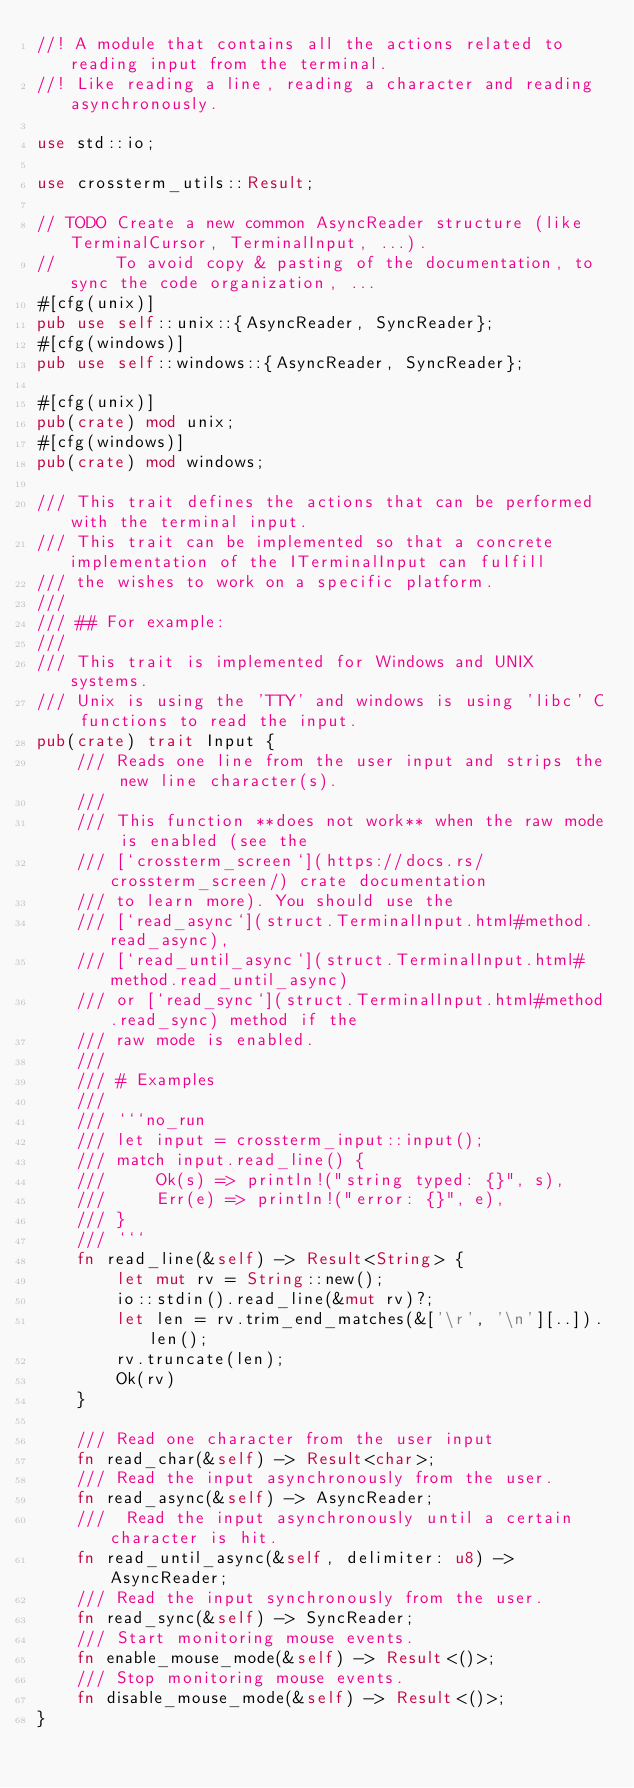Convert code to text. <code><loc_0><loc_0><loc_500><loc_500><_Rust_>//! A module that contains all the actions related to reading input from the terminal.
//! Like reading a line, reading a character and reading asynchronously.

use std::io;

use crossterm_utils::Result;

// TODO Create a new common AsyncReader structure (like TerminalCursor, TerminalInput, ...).
//      To avoid copy & pasting of the documentation, to sync the code organization, ...
#[cfg(unix)]
pub use self::unix::{AsyncReader, SyncReader};
#[cfg(windows)]
pub use self::windows::{AsyncReader, SyncReader};

#[cfg(unix)]
pub(crate) mod unix;
#[cfg(windows)]
pub(crate) mod windows;

/// This trait defines the actions that can be performed with the terminal input.
/// This trait can be implemented so that a concrete implementation of the ITerminalInput can fulfill
/// the wishes to work on a specific platform.
///
/// ## For example:
///
/// This trait is implemented for Windows and UNIX systems.
/// Unix is using the 'TTY' and windows is using 'libc' C functions to read the input.
pub(crate) trait Input {
    /// Reads one line from the user input and strips the new line character(s).
    ///
    /// This function **does not work** when the raw mode is enabled (see the
    /// [`crossterm_screen`](https://docs.rs/crossterm_screen/) crate documentation
    /// to learn more). You should use the
    /// [`read_async`](struct.TerminalInput.html#method.read_async),
    /// [`read_until_async`](struct.TerminalInput.html#method.read_until_async)
    /// or [`read_sync`](struct.TerminalInput.html#method.read_sync) method if the
    /// raw mode is enabled.
    ///
    /// # Examples
    ///
    /// ```no_run
    /// let input = crossterm_input::input();
    /// match input.read_line() {
    ///     Ok(s) => println!("string typed: {}", s),
    ///     Err(e) => println!("error: {}", e),
    /// }
    /// ```
    fn read_line(&self) -> Result<String> {
        let mut rv = String::new();
        io::stdin().read_line(&mut rv)?;
        let len = rv.trim_end_matches(&['\r', '\n'][..]).len();
        rv.truncate(len);
        Ok(rv)
    }

    /// Read one character from the user input
    fn read_char(&self) -> Result<char>;
    /// Read the input asynchronously from the user.
    fn read_async(&self) -> AsyncReader;
    ///  Read the input asynchronously until a certain character is hit.
    fn read_until_async(&self, delimiter: u8) -> AsyncReader;
    /// Read the input synchronously from the user.
    fn read_sync(&self) -> SyncReader;
    /// Start monitoring mouse events.
    fn enable_mouse_mode(&self) -> Result<()>;
    /// Stop monitoring mouse events.
    fn disable_mouse_mode(&self) -> Result<()>;
}
</code> 